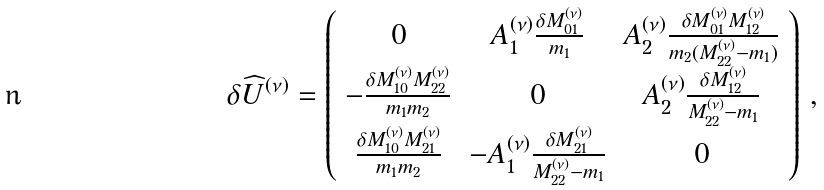Convert formula to latex. <formula><loc_0><loc_0><loc_500><loc_500>\delta \widehat { U } ^ { ( \nu ) } = \left ( \begin{array} { c c c } 0 & A ^ { ( \nu ) } _ { 1 } \frac { \delta M ^ { ( \nu ) } _ { 0 1 } } { m _ { 1 } } & A ^ { ( \nu ) } _ { 2 } \frac { \delta M ^ { ( \nu ) } _ { 0 1 } M ^ { ( \nu ) } _ { 1 2 } } { m _ { 2 } ( M ^ { ( \nu ) } _ { 2 2 } - m _ { 1 } ) } \\ - \frac { \delta M ^ { ( \nu ) } _ { 1 0 } M ^ { ( \nu ) } _ { 2 2 } } { m _ { 1 } m _ { 2 } } & 0 & A ^ { ( \nu ) } _ { 2 } \frac { \delta M ^ { ( \nu ) } _ { 1 2 } } { M ^ { ( \nu ) } _ { 2 2 } - m _ { 1 } } \\ \frac { \delta M ^ { ( \nu ) } _ { 1 0 } M ^ { ( \nu ) } _ { 2 1 } } { m _ { 1 } m _ { 2 } } & - A ^ { ( \nu ) } _ { 1 } \frac { \delta M ^ { ( \nu ) } _ { 2 1 } } { M ^ { ( \nu ) } _ { 2 2 } - m _ { 1 } } & 0 \end{array} \right ) \, ,</formula> 